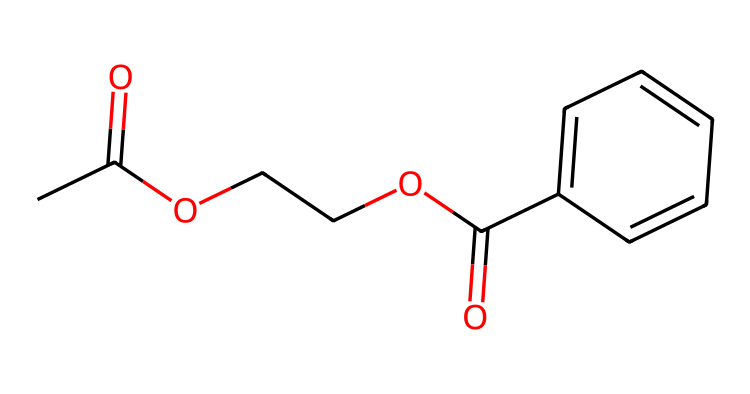What is the molecular formula of the compound? The compound can be analyzed to count the number of carbon, hydrogen, and oxygen atoms: There are 11 carbon atoms, 12 hydrogen atoms, and 4 oxygen atoms, giving the molecular formula C11H12O4.
Answer: C11H12O4 How many functional groups are present in this structure? The structure contains two ester groups (–COO–) and one carboxylic acid group (–COOH), resulting in three functional groups in total.
Answer: 3 What type of polymerization is involved in creating synthetic fibers for this structure? The presence of ester linkages indicates that this compound results from condensation polymerization, commonly used to create synthetic fabrics by linking monomers through the elimination of small molecules like water.
Answer: condensation What role does the aromatic ring play in the properties of this compound? The aromatic ring (c1ccc(cc1)) contributes rigidity and strength to the fiber, enhancing the mechanical properties and stability of the synthetic polymer used in costumes.
Answer: rigidity Which part of the molecule contributes to its solubility in organic solvents? The ester groups (–COO–) in this structure create polar regions that enhance solubility in organic solvents, allowing the synthetic fiber to dissolve and be processed effectively.
Answer: ester groups Is this compound biodegradable? Given the synthetic nature of the ester groups used and the overall structure, this compound is generally not considered biodegradable, as synthetic fibers typically resist decomposition.
Answer: no 